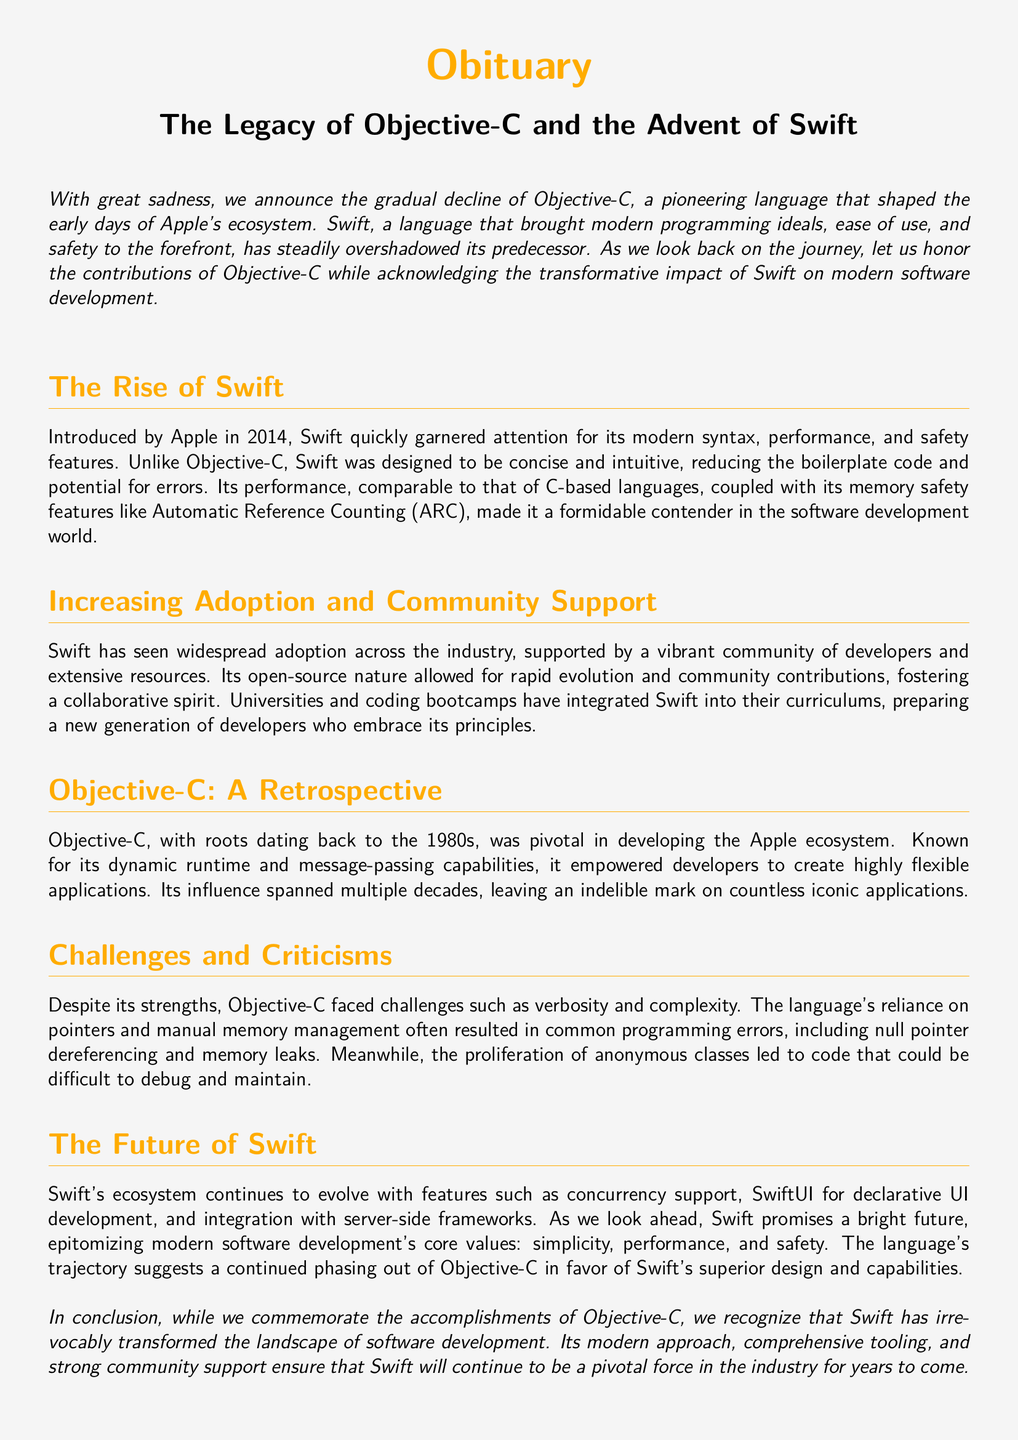What year was Swift introduced? The document states that Swift was introduced by Apple in 2014.
Answer: 2014 What programming language is known for its dynamic runtime? The document mentions Objective-C as a language known for its dynamic runtime.
Answer: Objective-C What feature of Swift reduces potential for errors? The document highlights that Swift's design reduces boilerplate code and potential for errors.
Answer: Conciseness What is one of the challenges faced by Objective-C? The document lists verbosity and complexity as challenges faced by Objective-C.
Answer: Verbosity What does Swift promise for the future of software development? The document asserts that Swift promises simplicity, performance, and safety for future software development.
Answer: Simplicity, performance, and safety What important feature does SwiftUI provide? The document states that SwiftUI provides declarative UI development.
Answer: Declarative UI development What was a major complaint regarding anonymous classes in Objective-C? The document cites that anonymous classes led to code that could be difficult to debug and maintain.
Answer: Difficult to debug and maintain What programming ideal did Swift bring to modern development? The document claims that Swift brought modern programming ideals to the forefront.
Answer: Modern programming ideals Which language's decline does the document discuss? The document discusses the decline of Objective-C.
Answer: Objective-C 